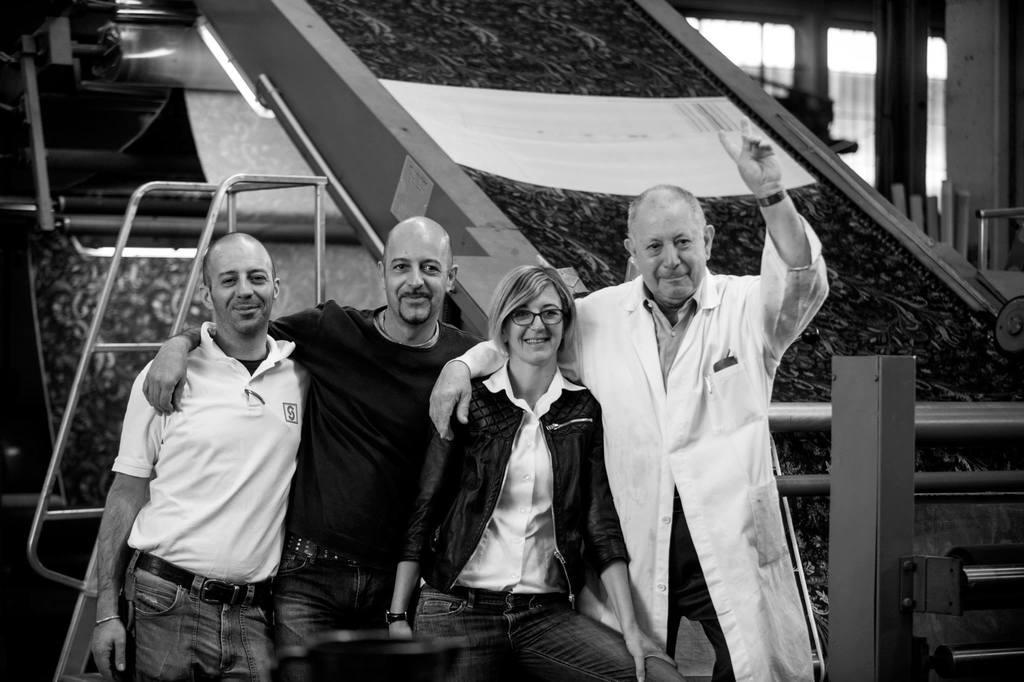Can you describe this image briefly? There are persons in different color dresses, smiling and standing. In the background, there are other objects. 